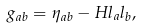<formula> <loc_0><loc_0><loc_500><loc_500>g _ { a b } = \eta _ { a b } - H l _ { a } l _ { b } ,</formula> 